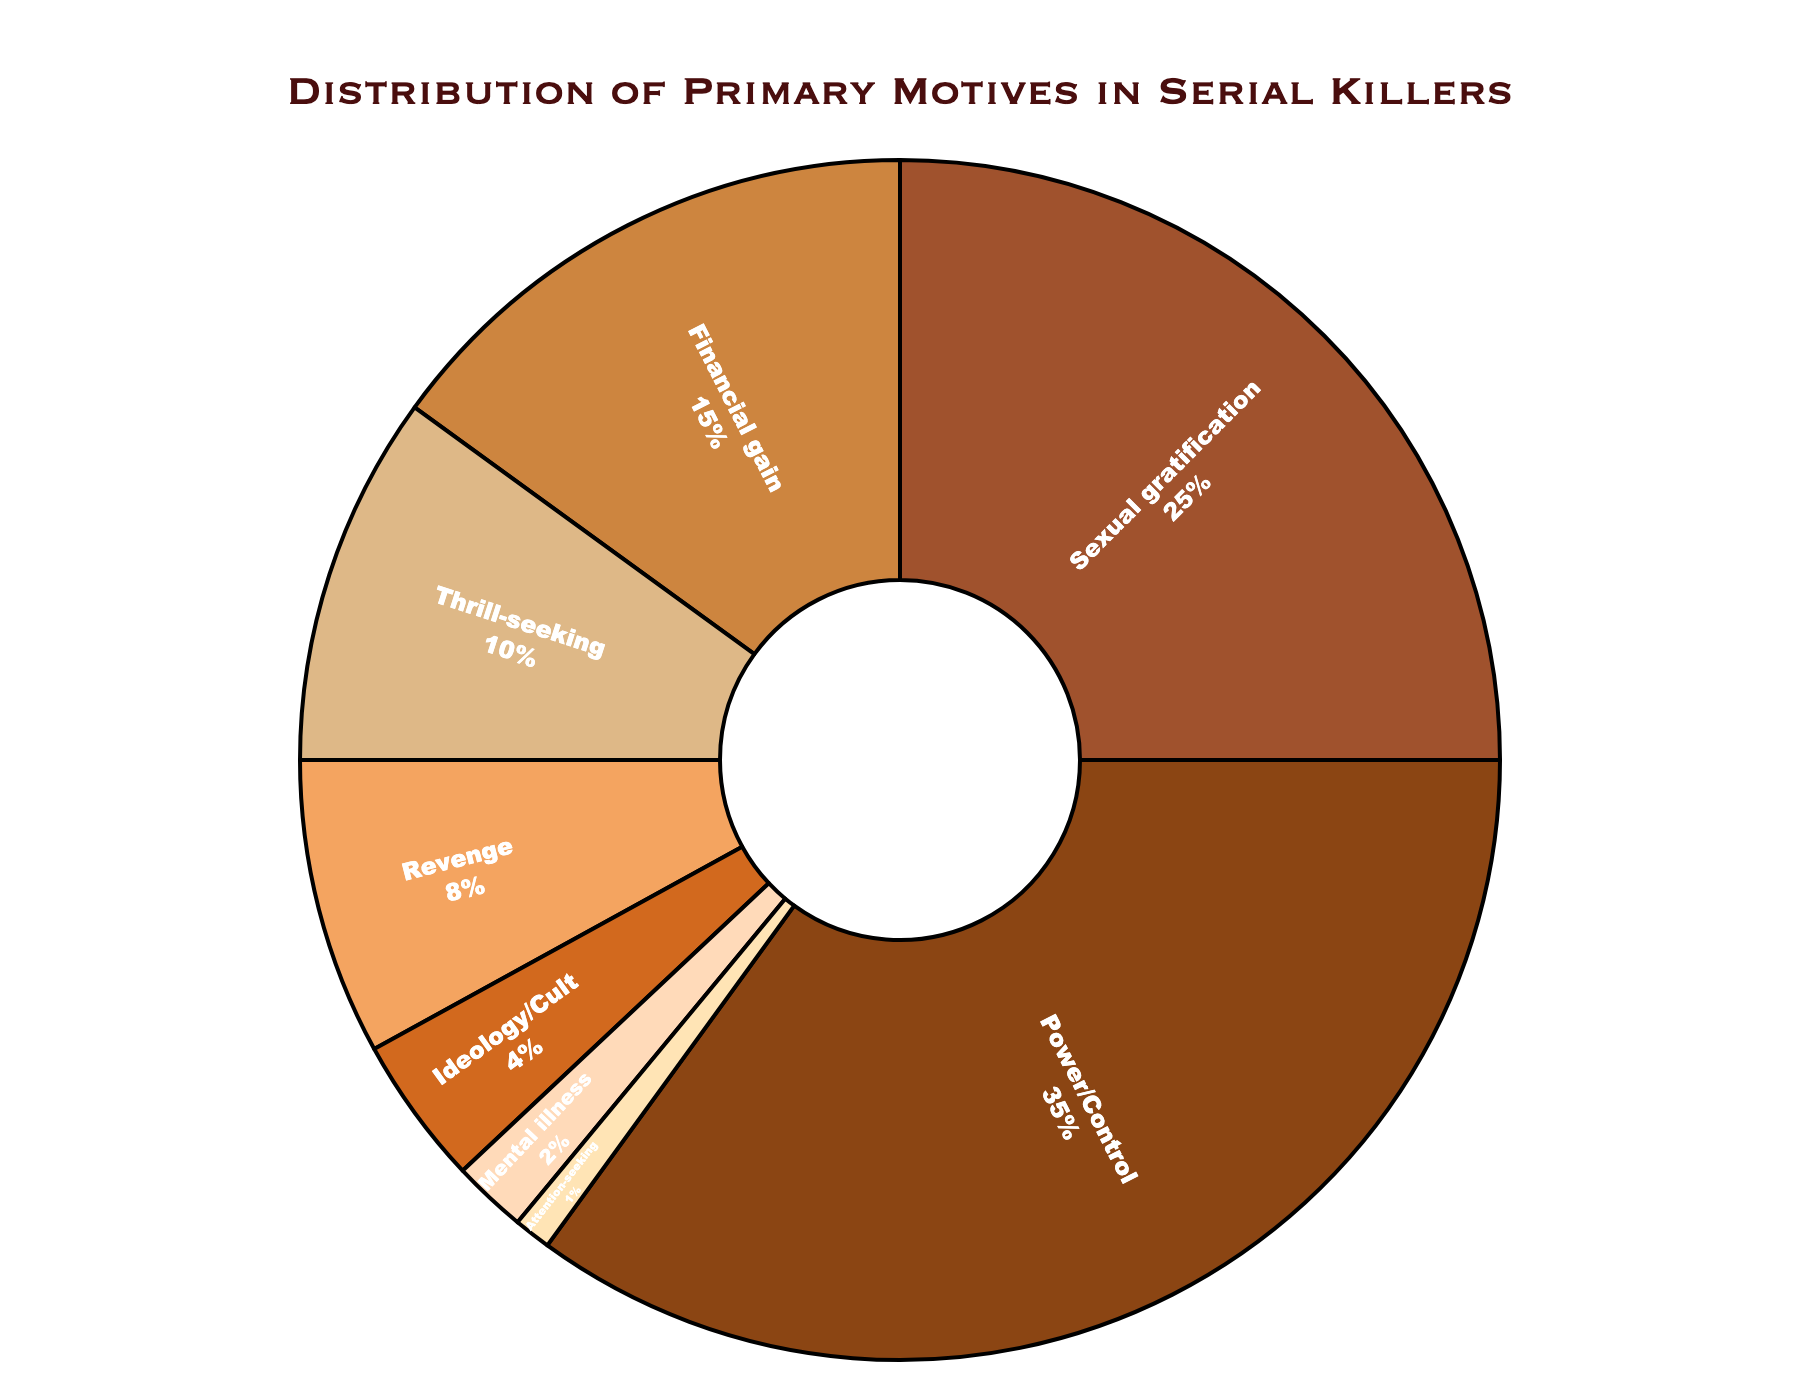What's the largest motive category represented in the pie chart? The largest motive category can be identified by referring to the segment with the highest percentage. In this case, "Power/Control" represents 35% of the motives, making it the largest category.
Answer: Power/Control Which motive category has the least representation in the pie chart? The smallest segment is identified by referring to the category with the lowest percentage of the overall distribution. In this case, "Attention-seeking" represents only 1%, making it the least represented category.
Answer: Attention-seeking What is the combined percentage of the "Financial gain" and "Thrill-seeking" categories? To find the combined percentage, add the individual percentages of "Financial gain" (15%) and "Thrill-seeking" (10%). Thus, the combined percentage is 15% + 10% = 25%.
Answer: 25% How many percentage points higher is "Power/Control" than "Sexual gratification"? To determine the difference, subtract the percentage of "Sexual gratification" (25%) from "Power/Control" (35%). The calculation is 35% - 25% = 10%.
Answer: 10% Rank the top three motives by their percentage. Refer to each segment's percentage and list the top three in descending order. The top three motives are: "Power/Control" (35%), "Sexual gratification" (25%), and "Financial gain" (15%).
Answer: Power/Control, Sexual gratification, Financial gain What is the average percentage of the categories "Revenge," "Ideology/Cult," and "Mental illness"? First, add the percentages of these categories: "Revenge" (8%), "Ideology/Cult" (4%), and "Mental illness" (2%). The sum is 8% + 4% + 2% = 14%. The average is then calculated by dividing by the number of categories: 14% / 3 ≈ 4.67%.
Answer: 4.67% Are there more categories with a percentage greater than 10% or categories with a percentage less than 10%? Count the number of categories with a percentage greater than 10%: "Power/Control" (35%), "Sexual gratification" (25%), and "Financial gain" (15%), totaling 3 categories. Similarly, count those less than 10%: "Thrill-seeking" (10%), "Revenge" (8%), "Ideology/Cult" (4%), "Mental illness" (2%), and "Attention-seeking" (1%), totaling 5 categories. Thus, there are more categories with a percentage less than 10%.
Answer: Less than 10% What percentage of the motives fall into "Mental illness" and "Attention-seeking" combined? Add the percentages of "Mental illness" (2%) and "Attention-seeking" (1%). The total combined percentage is 2% + 1% = 3%.
Answer: 3% What is the visual distinction used to differentiate the categories in the pie chart? The visual distinction includes different colors for each category segment along with text labels and percentages inside each segment. The segments also have a black outline for clearer separation.
Answer: Different colors and text labels 